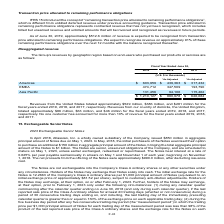From Atlassian Plc's financial document, What are the revenue amounts from the United States for fiscal years ended 2017, 2018 and 2019 respectively? The document contains multiple relevant values: $281 million, $386 million, $529 million. From the document: "United States totaled approximately $529 million, $386 million, and $281 million for the aled approximately $529 million, $386 million, and $281 milli..." Also, What are the revenue amounts from the United Kingdom for fiscal years ended 2017, 2018 and 2019 respectively? The document contains multiple relevant values: $46 million, $63 million, $86 million. From the document: "otaled approximately $86 million, $63 million, and $46 million for the fiscal years ended 2019, 2018, and 2017, respectively. No one customer has acco..." Also, What is the revenue amount from Asia Pacific for fiscal year ended 2019? According to the financial document, 131,456 (in thousands). The relevant text states: "Asia Pacific 131,456 94,106 115,462..." Also, In fiscal year ended 2019, how many geographic regions have more than $500,000 thousand of revenues? Based on the analysis, there are 1 instances. The counting process: Americas. Also, can you calculate: What is the percentage constitution of the revenues from Asia Pacific among the total revenues in fiscal year ended 2017? Based on the calculation: 115,462/626,684, the result is 18.42 (percentage). This is based on the information: "Asia Pacific 131,456 94,106 115,462 $ 1,210,127 $ 880,978 $ 626,684..." The key data points involved are: 115,462, 626,684. Also, can you calculate: What is the difference in the revenues from Asia Pacific between fiscal years ended 2018 and 2019? Based on the calculation: 131,456-94,106, the result is 37350 (in thousands). This is based on the information: "Asia Pacific 131,456 94,106 115,462 Asia Pacific 131,456 94,106 115,462..." The key data points involved are: 131,456, 94,106. 